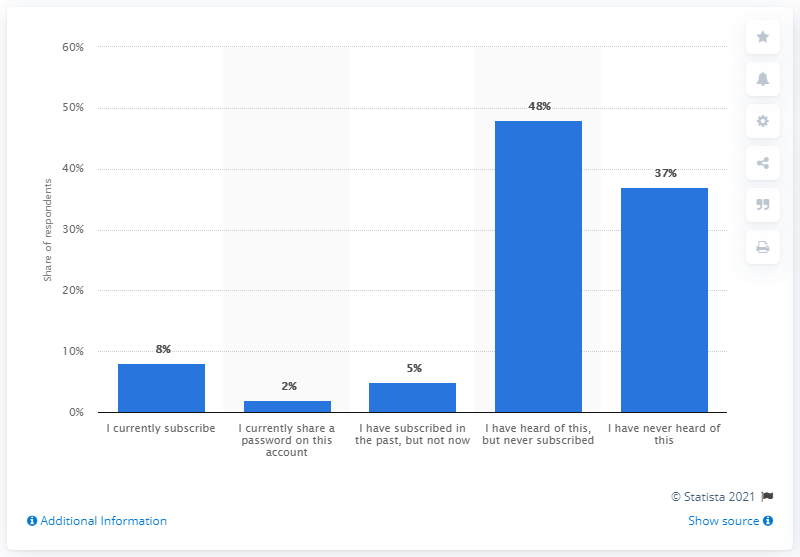Draw attention to some important aspects in this diagram. The current ratio of adults who subscribe and share a password on this account is 4 to 1. According to recent data, approximately 8% of adults currently subscribe to Vudu. 